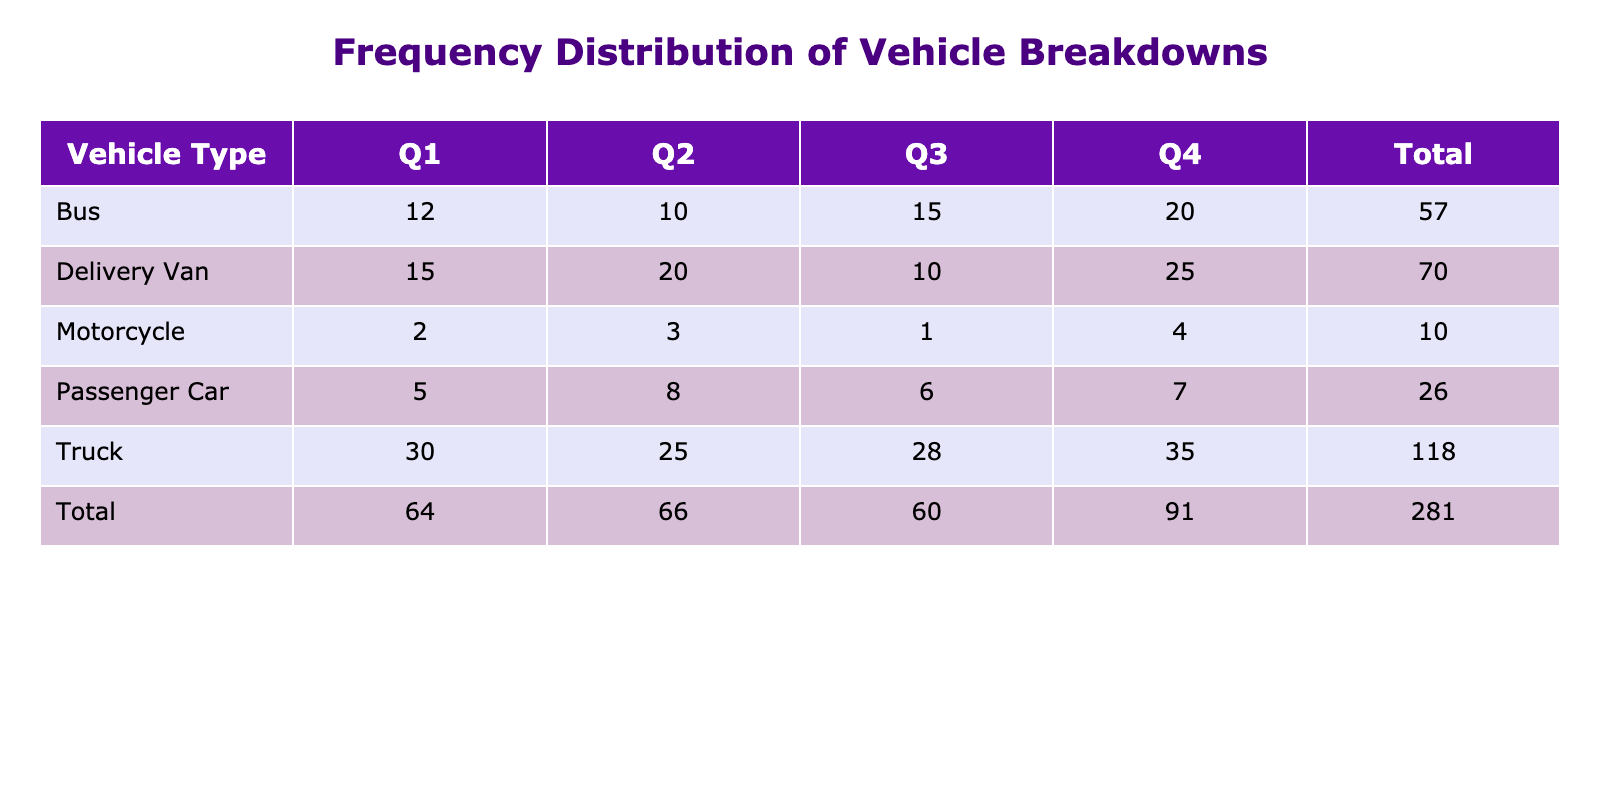What is the total number of breakdowns reported for Delivery Vans in Q2? There are 4 quarters in the data. Looking specifically at the Delivery Van row and the Quarter Q2, the table shows 20.
Answer: 20 How many breakdowns did Passenger Cars report in total for all quarters? To find the total, add the breakdowns for each quarter: 5 (Q1) + 8 (Q2) + 6 (Q3) + 7 (Q4) = 26.
Answer: 26 Which vehicle type had the highest number of breakdowns in Q4? By comparing the Q4 breakdowns, the values are: Delivery Van (25), Truck (35), Passenger Car (7), Bus (20), and Motorcycle (4). The Truck has the highest value at 35.
Answer: Truck Did any vehicle type report fewer than 3 breakdowns in Q3? Checking the Q3 breakdowns: Delivery Van (10), Truck (28), Passenger Car (6), Bus (15), and Motorcycle (1). The Motorcycle reported just 1 breakdown, which is fewer than 3.
Answer: Yes What is the average number of breakdowns for Buses across all quarters? The total breakdowns for Buses are 12 (Q1) + 10 (Q2) + 15 (Q3) + 20 (Q4) = 57. Since there are 4 quarters, the average is 57 / 4 = 14.25.
Answer: 14.25 Which quarter saw the most breakdowns for Trucks? Looking at the breakdowns for Trucks in each quarter: Q1 had 30, Q2 had 25, Q3 had 28, and Q4 had 35. The most breakdowns were reported in Q4 with 35 breakdowns.
Answer: Q4 How many more total breakdowns were reported for Delivery Vans than for Motorcycles over the entire year? First, sum the breakdowns for Delivery Vans: 15 + 20 + 10 + 25 = 70. Next, sum the breakdowns for Motorcycles: 2 + 3 + 1 + 4 = 10. The difference is 70 - 10 = 60.
Answer: 60 What percentage of total breakdowns in Q1 were reported by Trucks? The total breakdowns in Q1 are: Delivery Van (15), Truck (30), Passenger Car (5), Bus (12), and Motorcycle (2); summing these gives 64. The breakdowns reported by Trucks (30) as a percentage of total Q1 breakdowns is (30 / 64) * 100 = 46.875%.
Answer: 46.88% 